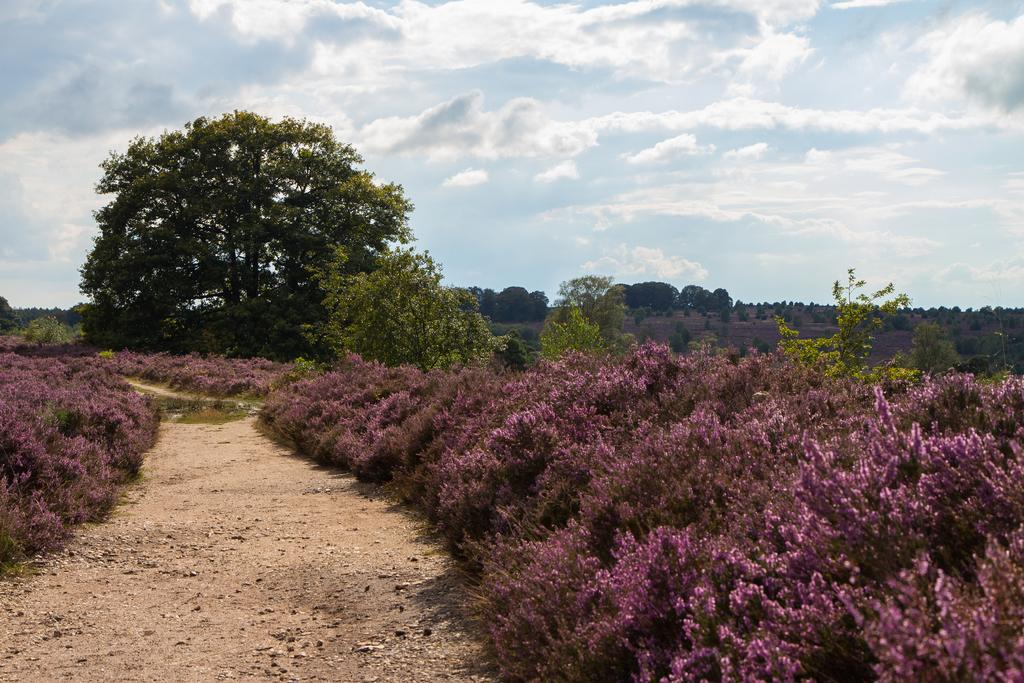What type of terrain is visible in the image? There is ground visible in the image. What type of vegetation can be seen in the image? There are bushes and trees in the image. What is visible in the background of the image? The sky is visible in the background of the image. What can be observed in the sky? Clouds are present in the sky. Can you describe the sofa in the image? There is no sofa present in the image. What type of line can be seen connecting the clouds in the image? There is no line connecting the clouds in the image; the clouds are scattered in the sky. 